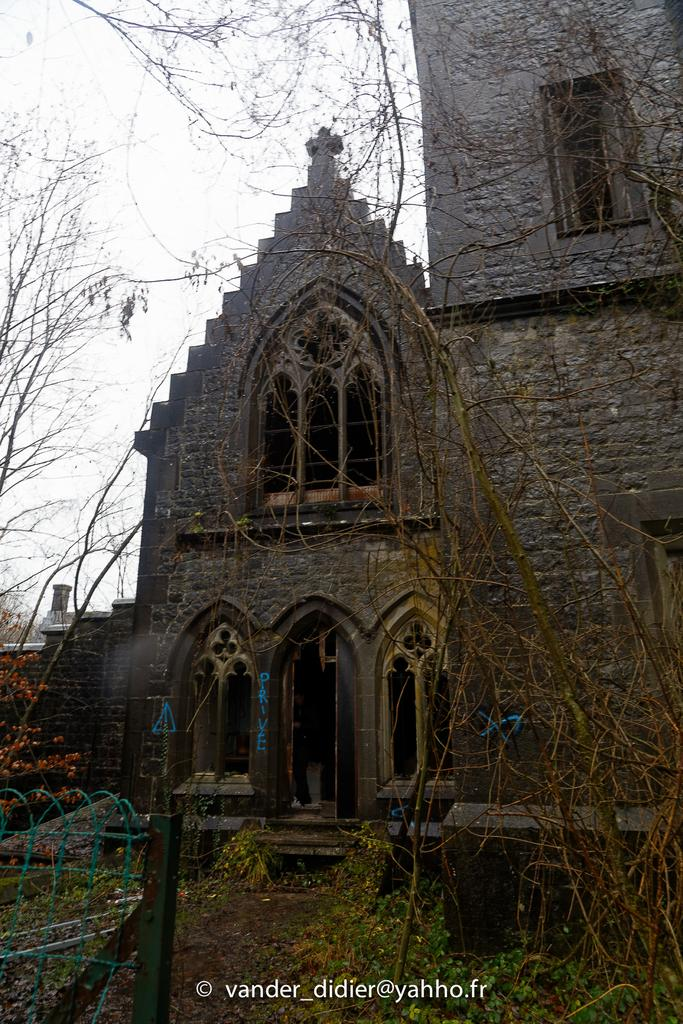What is the main subject of the image? The main subject of the image is a church. What type of natural elements can be seen in the image? There are trees in the image. What is visible at the top of the image? The sky is visible at the top of the image. Can you tell me how many kittens are playing on the roof of the church in the image? There are no kittens present on the roof of the church in the image. What type of achievement is the church celebrating in the image? The image does not provide any information about the church celebrating an achievement. 